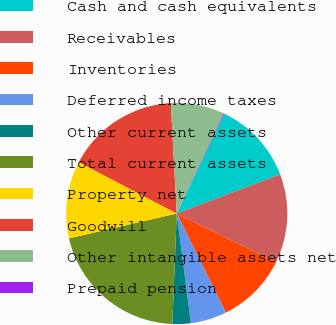Convert chart to OTSL. <chart><loc_0><loc_0><loc_500><loc_500><pie_chart><fcel>Cash and cash equivalents<fcel>Receivables<fcel>Inventories<fcel>Deferred income taxes<fcel>Other current assets<fcel>Total current assets<fcel>Property net<fcel>Goodwill<fcel>Other intangible assets net<fcel>Prepaid pension<nl><fcel>12.15%<fcel>13.01%<fcel>10.43%<fcel>5.27%<fcel>2.68%<fcel>20.76%<fcel>11.29%<fcel>16.46%<fcel>7.85%<fcel>0.1%<nl></chart> 